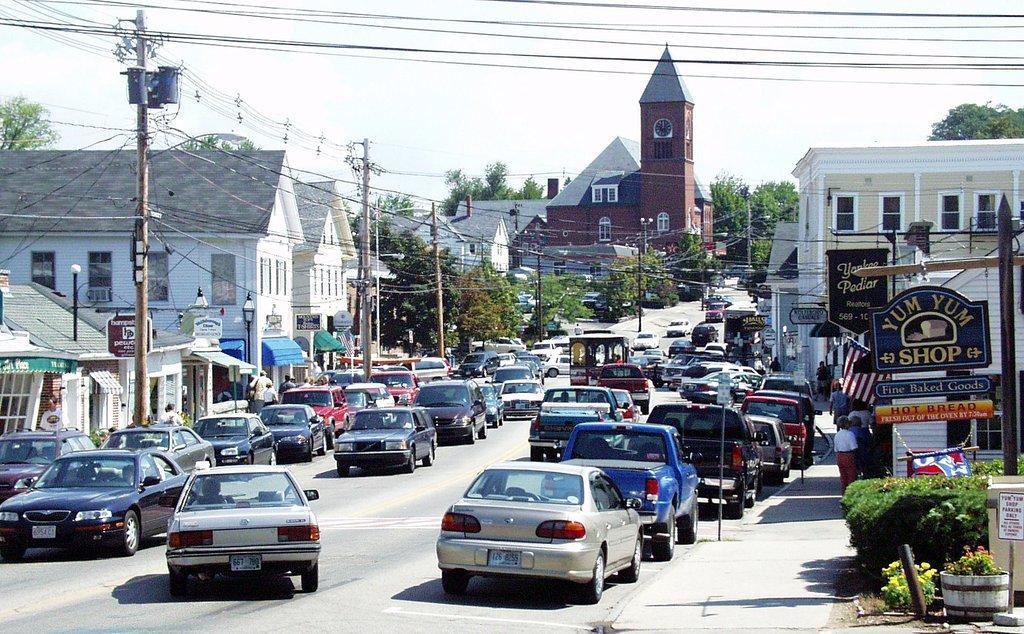In one or two sentences, can you explain what this image depicts? In this image there are vehicles on the road. There are current poles with wires. There are street lights. There are plants. In the background of the image there are trees, buildings and sky. On the right side of the image there are boards. 